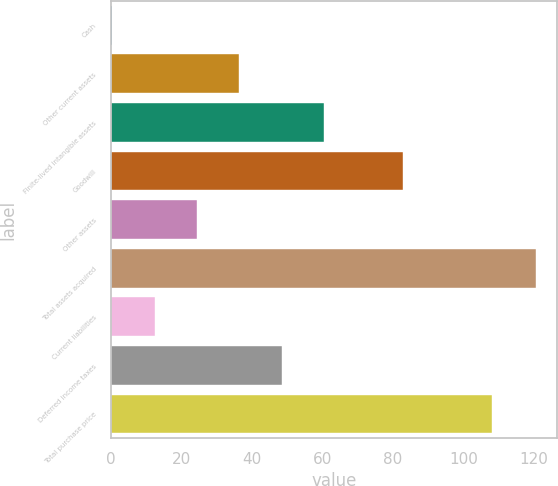<chart> <loc_0><loc_0><loc_500><loc_500><bar_chart><fcel>Cash<fcel>Other current assets<fcel>Finite-lived intangible assets<fcel>Goodwill<fcel>Other assets<fcel>Total assets acquired<fcel>Current liabilities<fcel>Deferred income taxes<fcel>Total purchase price<nl><fcel>0.4<fcel>36.46<fcel>60.5<fcel>82.9<fcel>24.44<fcel>120.6<fcel>12.42<fcel>48.48<fcel>108.1<nl></chart> 